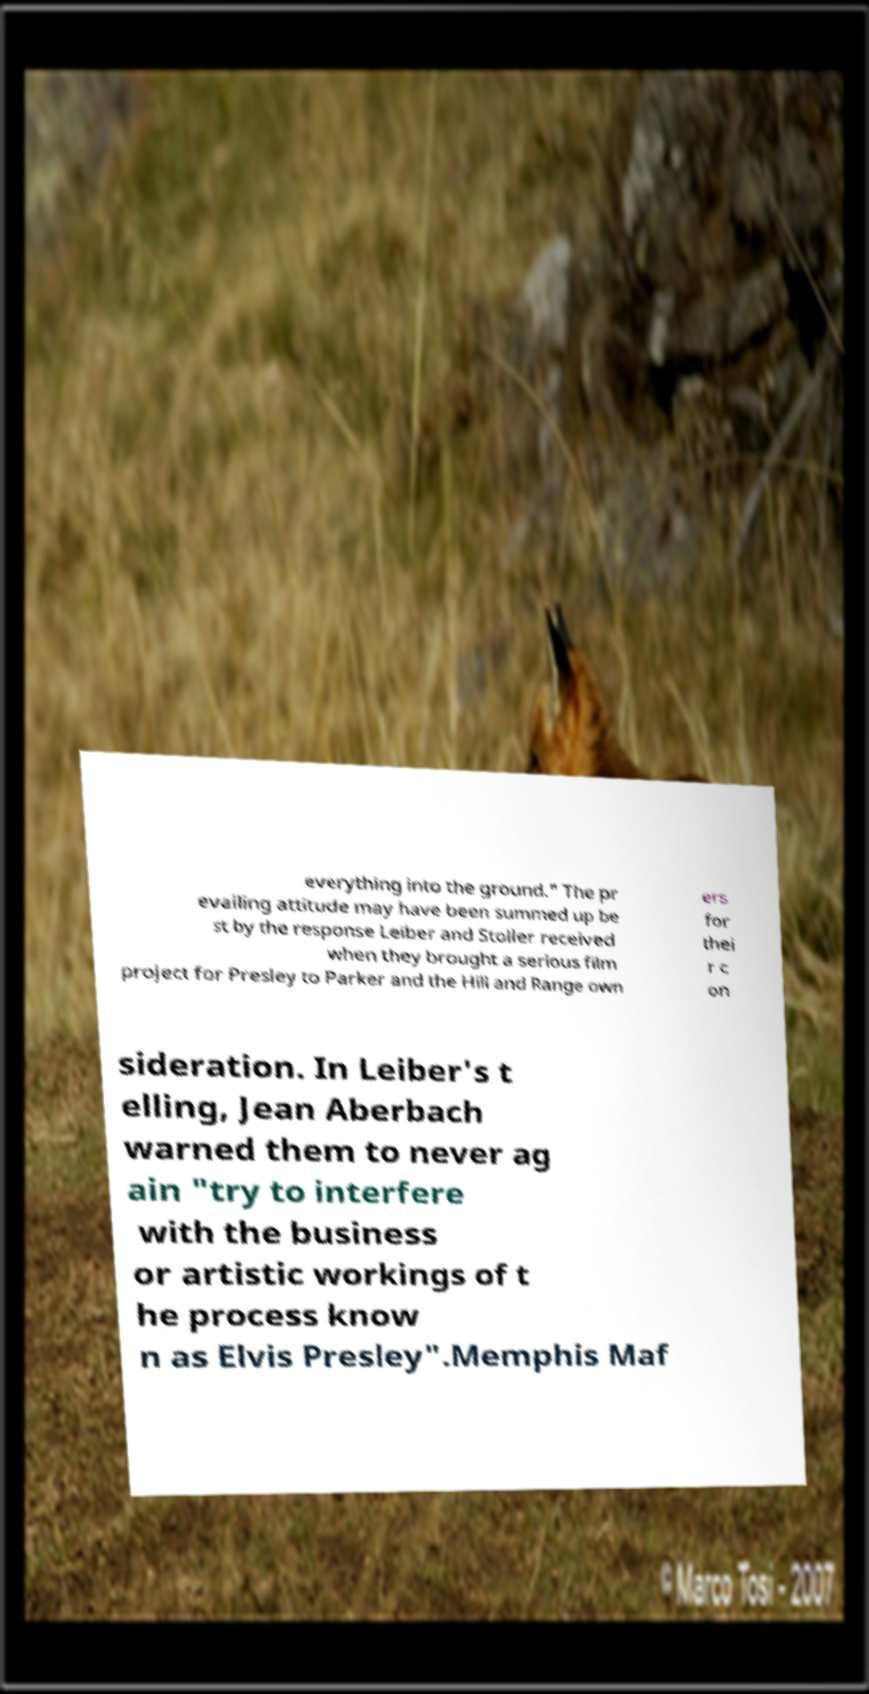Please identify and transcribe the text found in this image. everything into the ground." The pr evailing attitude may have been summed up be st by the response Leiber and Stoller received when they brought a serious film project for Presley to Parker and the Hill and Range own ers for thei r c on sideration. In Leiber's t elling, Jean Aberbach warned them to never ag ain "try to interfere with the business or artistic workings of t he process know n as Elvis Presley".Memphis Maf 